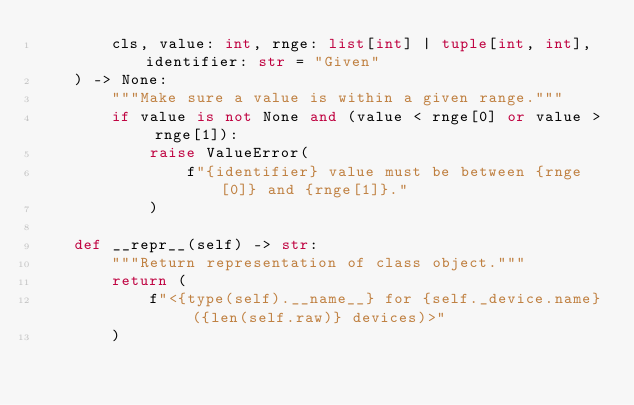<code> <loc_0><loc_0><loc_500><loc_500><_Python_>        cls, value: int, rnge: list[int] | tuple[int, int], identifier: str = "Given"
    ) -> None:
        """Make sure a value is within a given range."""
        if value is not None and (value < rnge[0] or value > rnge[1]):
            raise ValueError(
                f"{identifier} value must be between {rnge[0]} and {rnge[1]}."
            )

    def __repr__(self) -> str:
        """Return representation of class object."""
        return (
            f"<{type(self).__name__} for {self._device.name} ({len(self.raw)} devices)>"
        )
</code> 